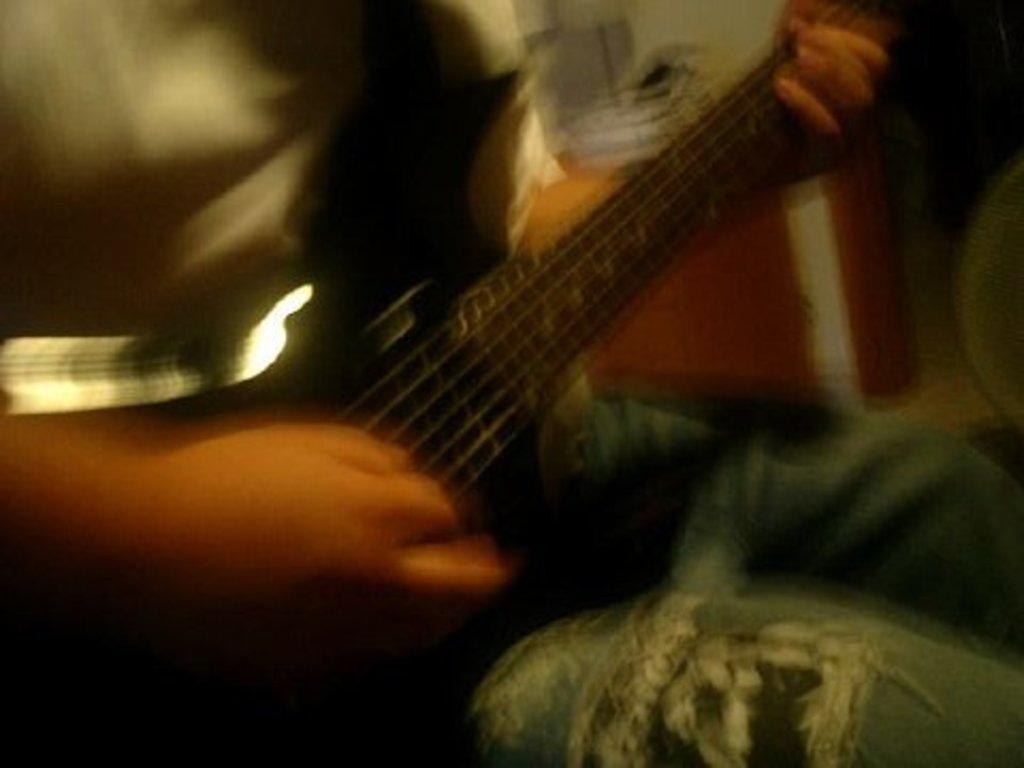Could you give a brief overview of what you see in this image? In this image a person is holding a guitar. He is sitting. Background is blurry. 